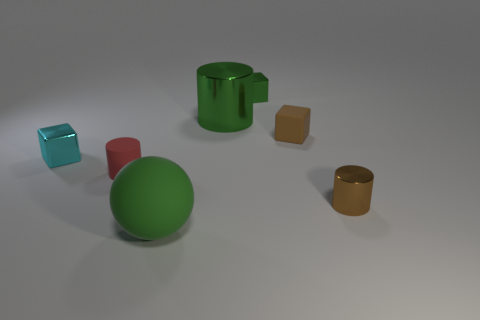Add 1 small brown metal things. How many objects exist? 8 Subtract all cylinders. How many objects are left? 4 Subtract 1 brown blocks. How many objects are left? 6 Subtract all green matte objects. Subtract all tiny metal blocks. How many objects are left? 4 Add 4 small red matte things. How many small red matte things are left? 5 Add 3 small brown cylinders. How many small brown cylinders exist? 4 